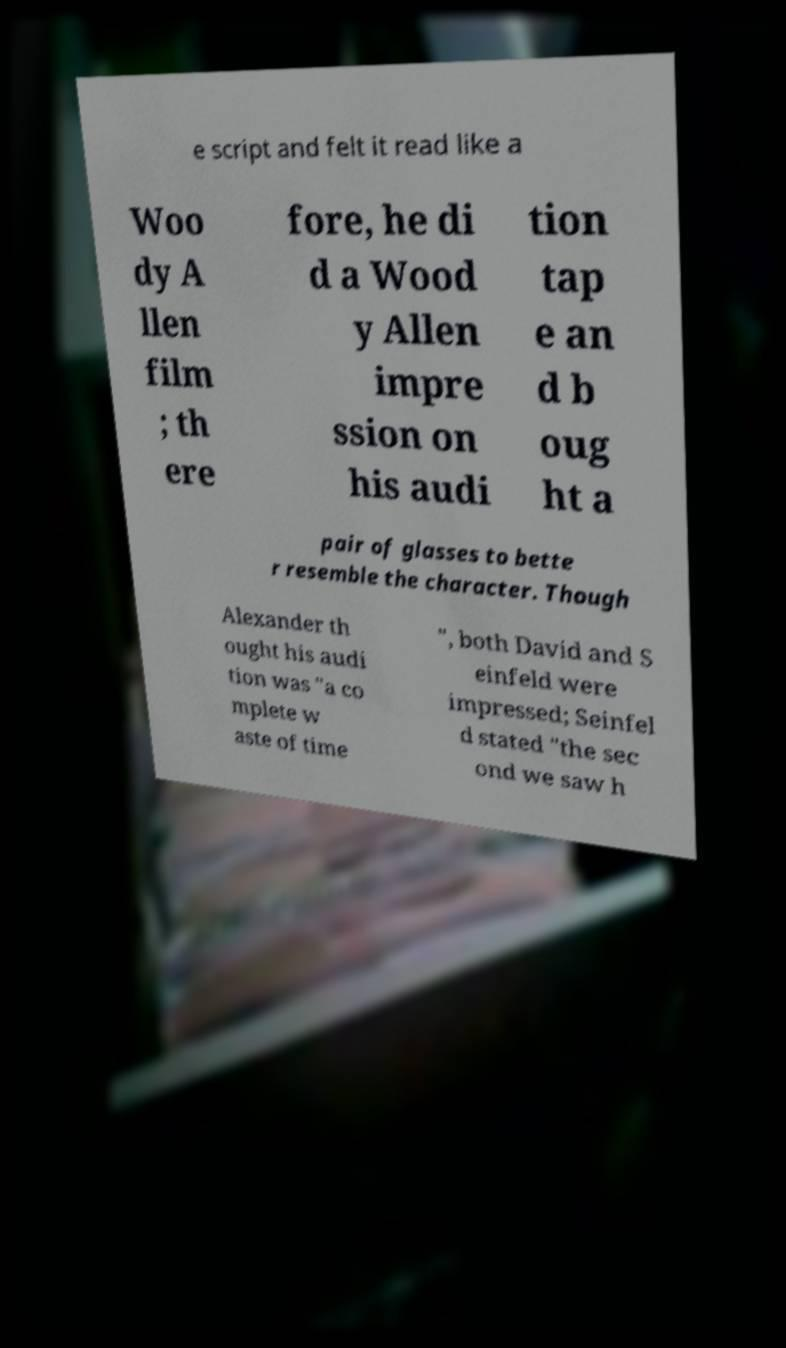For documentation purposes, I need the text within this image transcribed. Could you provide that? e script and felt it read like a Woo dy A llen film ; th ere fore, he di d a Wood y Allen impre ssion on his audi tion tap e an d b oug ht a pair of glasses to bette r resemble the character. Though Alexander th ought his audi tion was "a co mplete w aste of time ", both David and S einfeld were impressed; Seinfel d stated "the sec ond we saw h 